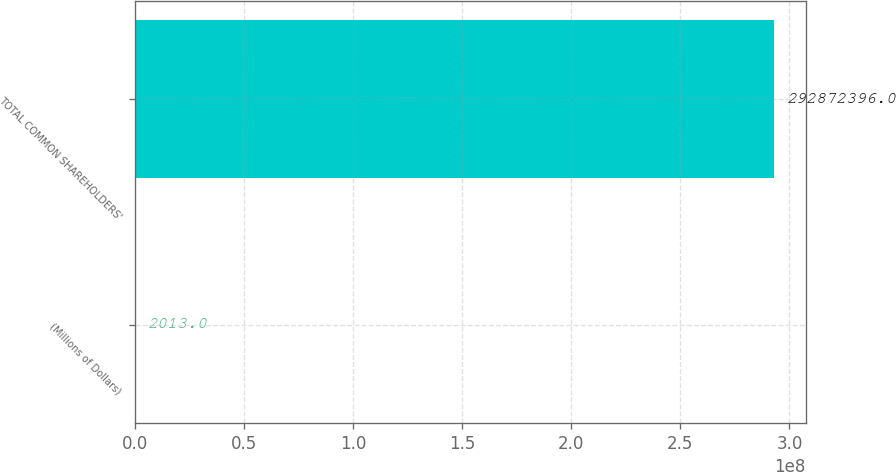Convert chart to OTSL. <chart><loc_0><loc_0><loc_500><loc_500><bar_chart><fcel>(Millions of Dollars)<fcel>TOTAL COMMON SHAREHOLDERS'<nl><fcel>2013<fcel>2.92872e+08<nl></chart> 